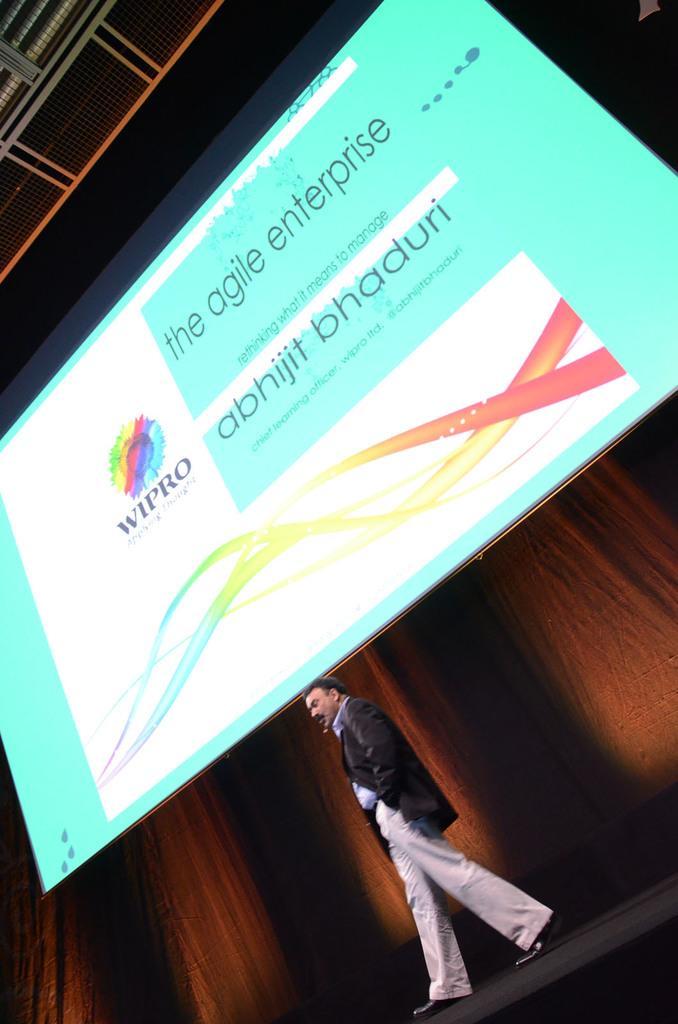Describe this image in one or two sentences. The man at the bottom of the picture wearing blue shirt and black blazer is walking. Behind him, it is brown in color. In the middle of the picture, we see a banner in green color with some text written on it. This picture might be clicked in the concert hall. 